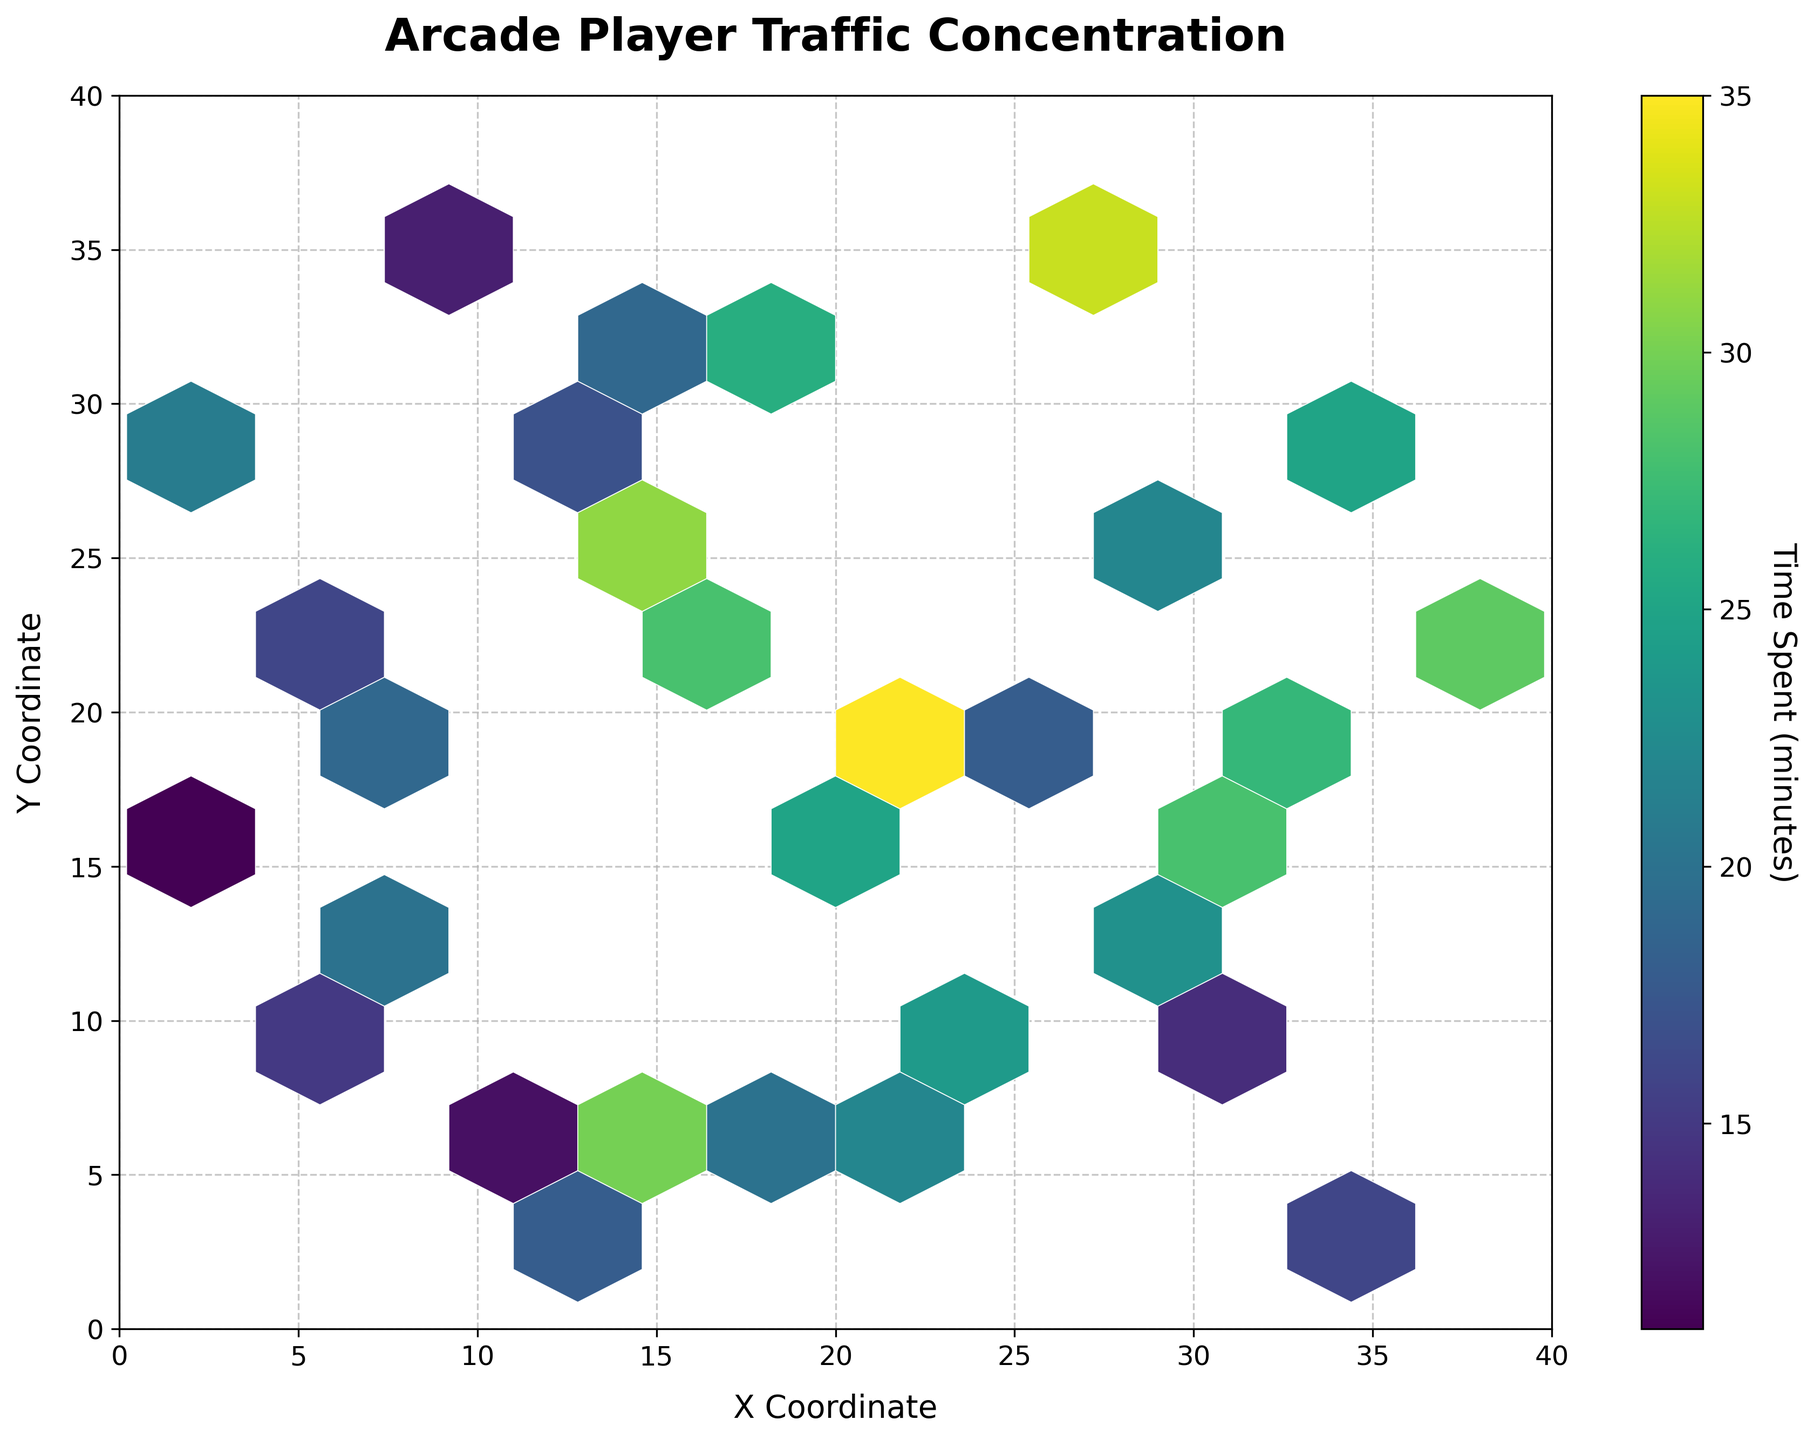What is the title of the plot? The title can be found at the top of the figure.
Answer: Arcade Player Traffic Concentration What do the X and Y axes represent in the plot? The X axis represents the X Coordinate, and the Y axis represents the Y Coordinate, as indicated by the labels on each axis.
Answer: X Coordinate and Y Coordinate What does the color bar represent in the plot? The color bar on the right side of the plot indicates the 'Time Spent (minutes)' at each machine.
Answer: Time Spent (minutes) What is the general trend of the highest concentration of player traffic in this arcade? Observing the plot, the highest concentration of player traffic is located in the central area, where darker hexagons are more densely packed.
Answer: Central area Which coordinate has the highest time spent and what is its value? By tracing the darkest hexagon in the plot to the color bar, and noting the coordinate, we find that the highest time spent is approximately 35 minutes.
Answer: 35 minutes In which area (quadrant) of the arcade is the player traffic the lowest? By examining the plot and looking for the lightest colored or sparsely populated hexagons, it's clear that the bottom-left quadrant has the lowest player traffic.
Answer: Bottom-left quadrant At which coordinates do players spend the most time? The coordinates can be found by identifying the darkest hexagons in the plot, which indicates high concentration and time spent.
Answer: Central coordinates (around the center) Between the coordinates (15,25) and (35,28), which has a higher time spent? By comparing the color intensity of these two coordinates using the hexagon color and the color bar, (15,25) has a higher time spent.
Answer: (15,25) How does the time spent at the top-right area of the plot compare to the time spent at the bottom-left area? By comparing the color densities in both areas, it's observed that the top-right area has darker hexagons than the bottom-left area, indicating more time spent.
Answer: Top-right area has higher time spent What is the range of the Y axis, and how does it help in understanding the player traffic distribution? The range of the Y axis is from 0 to 40, which helps in identifying the spread of player traffic across the arcade's vertical span.
Answer: 0 to 40 